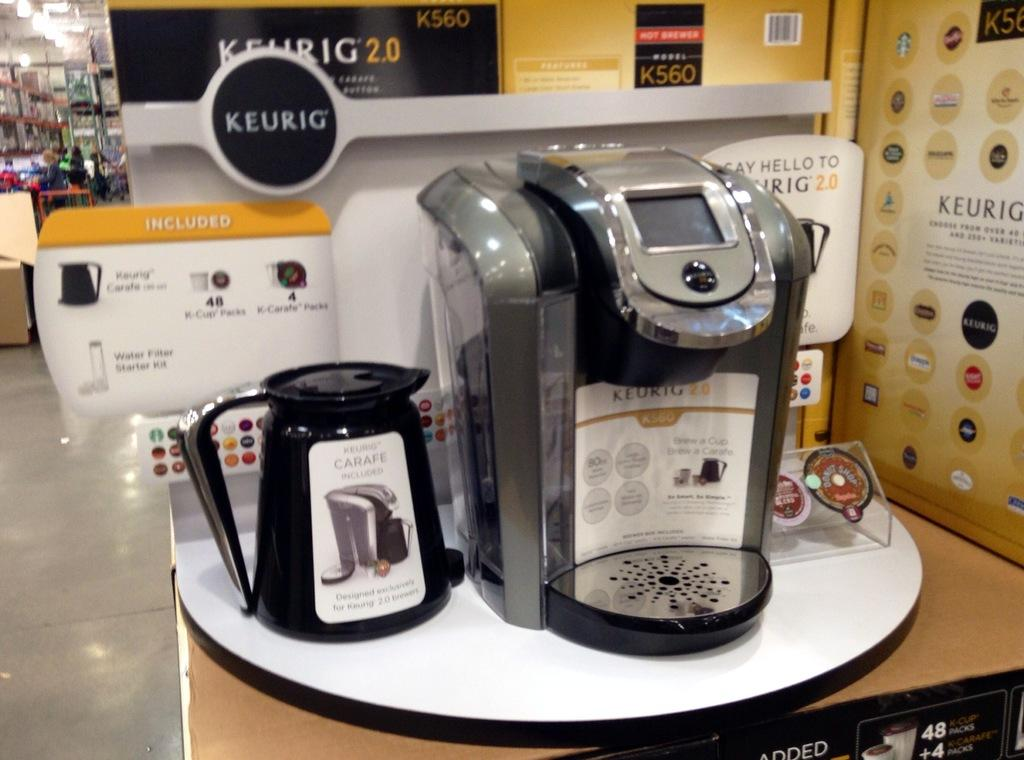<image>
Relay a brief, clear account of the picture shown. a Keurig display with the machine and pot 